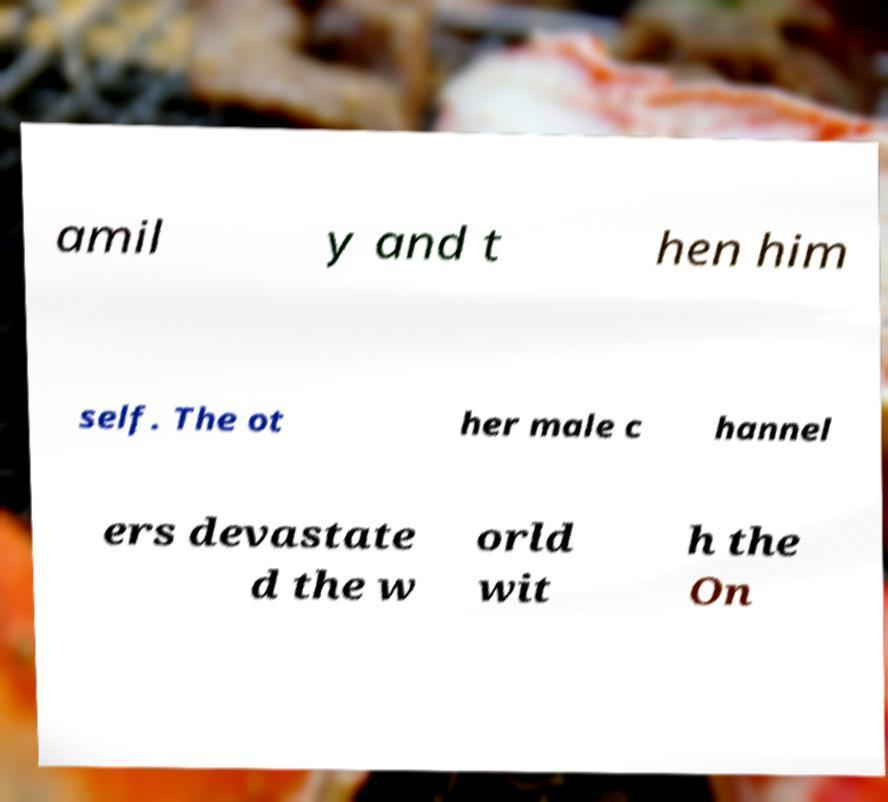Can you accurately transcribe the text from the provided image for me? amil y and t hen him self. The ot her male c hannel ers devastate d the w orld wit h the On 